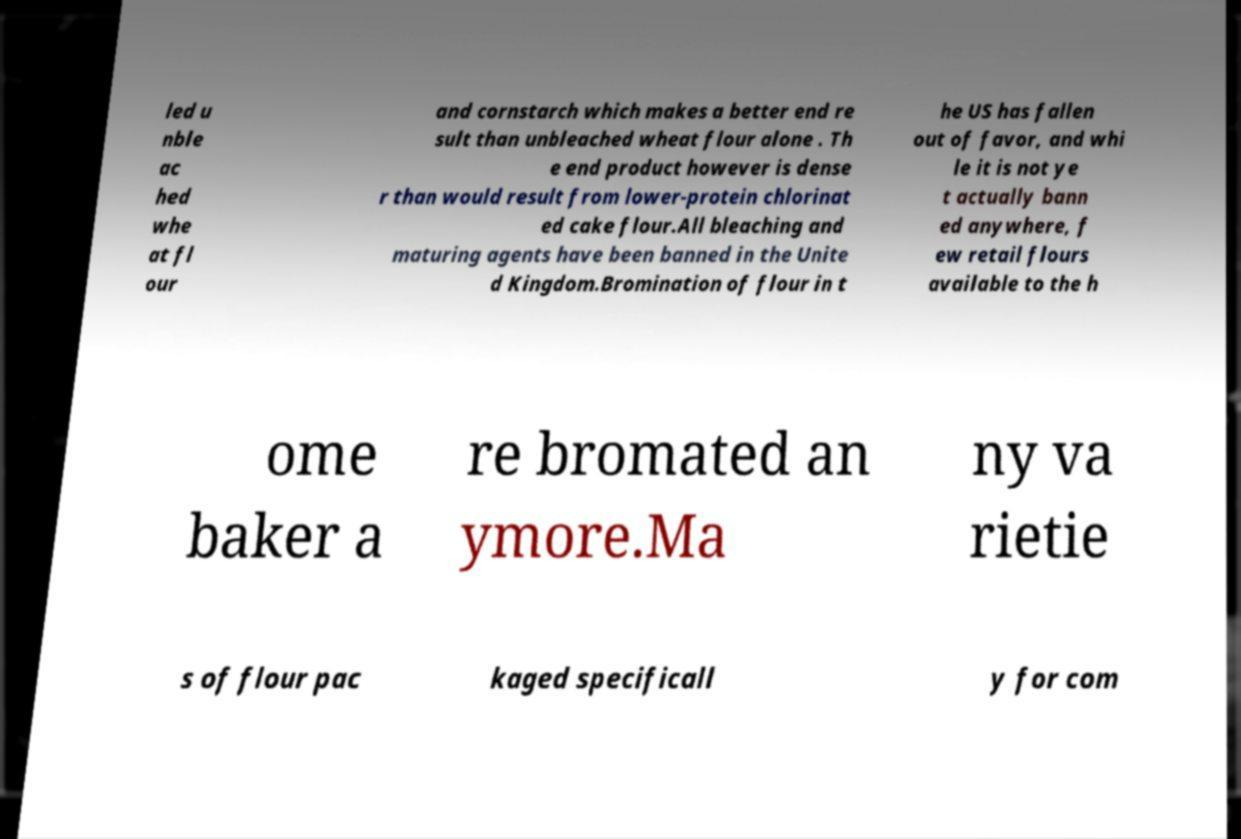For documentation purposes, I need the text within this image transcribed. Could you provide that? led u nble ac hed whe at fl our and cornstarch which makes a better end re sult than unbleached wheat flour alone . Th e end product however is dense r than would result from lower-protein chlorinat ed cake flour.All bleaching and maturing agents have been banned in the Unite d Kingdom.Bromination of flour in t he US has fallen out of favor, and whi le it is not ye t actually bann ed anywhere, f ew retail flours available to the h ome baker a re bromated an ymore.Ma ny va rietie s of flour pac kaged specificall y for com 